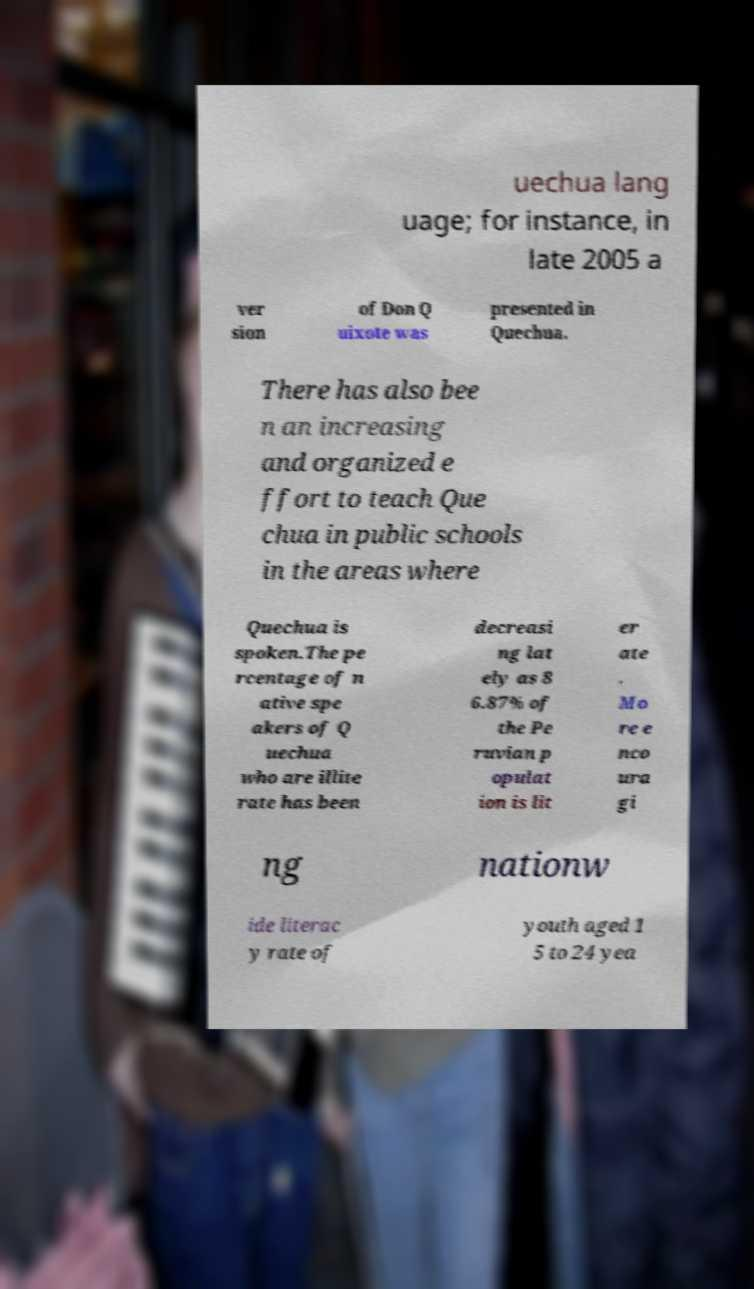There's text embedded in this image that I need extracted. Can you transcribe it verbatim? uechua lang uage; for instance, in late 2005 a ver sion of Don Q uixote was presented in Quechua. There has also bee n an increasing and organized e ffort to teach Que chua in public schools in the areas where Quechua is spoken.The pe rcentage of n ative spe akers of Q uechua who are illite rate has been decreasi ng lat ely as 8 6.87% of the Pe ruvian p opulat ion is lit er ate . Mo re e nco ura gi ng nationw ide literac y rate of youth aged 1 5 to 24 yea 